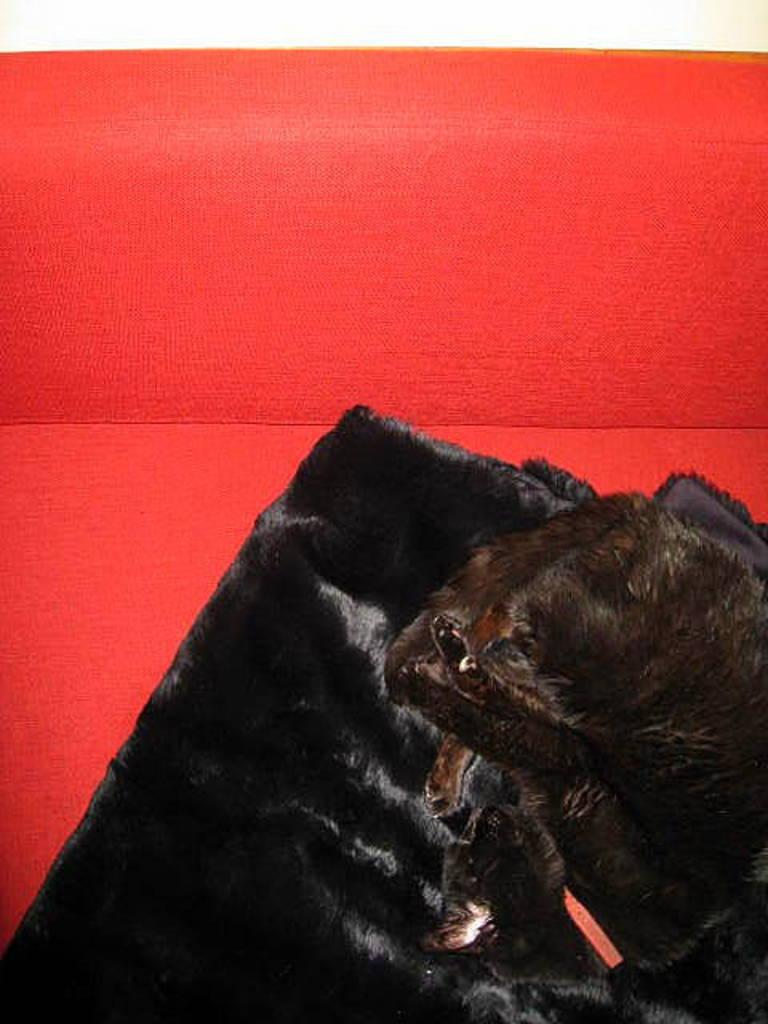What type of animal is in the image? There is a cat in the image. What is the cat doing in the image? The cat is sleeping on a blanket. What color is the blanket the cat is sleeping on? The blanket is black in color. What can be seen in the background of the image? There is a red sofa in the background of the image. What color is the cat in the image? The cat is also black in color. Can you see any planes flying over the yard in the image? There is no yard or planes visible in the image; it features a cat sleeping on a black blanket with a red sofa in the background. 